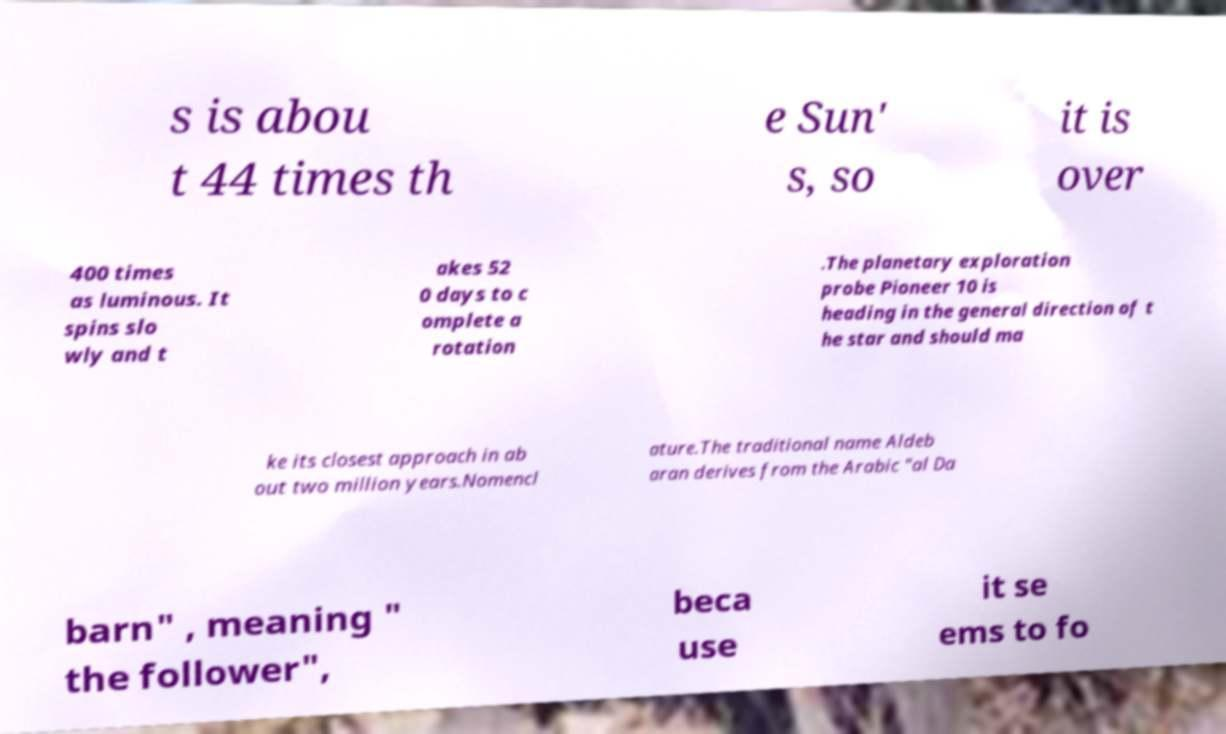Can you accurately transcribe the text from the provided image for me? s is abou t 44 times th e Sun' s, so it is over 400 times as luminous. It spins slo wly and t akes 52 0 days to c omplete a rotation .The planetary exploration probe Pioneer 10 is heading in the general direction of t he star and should ma ke its closest approach in ab out two million years.Nomencl ature.The traditional name Aldeb aran derives from the Arabic "al Da barn" , meaning " the follower", beca use it se ems to fo 